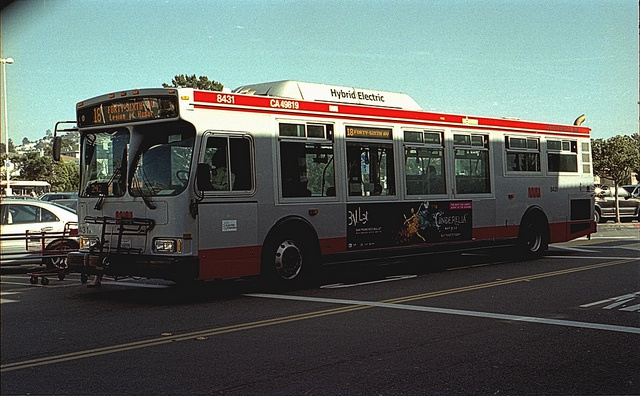Describe the objects in this image and their specific colors. I can see bus in black, gray, ivory, and red tones, car in black, ivory, gray, and darkgray tones, car in black, gray, beige, and darkgray tones, people in black, gray, and darkgreen tones, and car in black, gray, and darkgray tones in this image. 